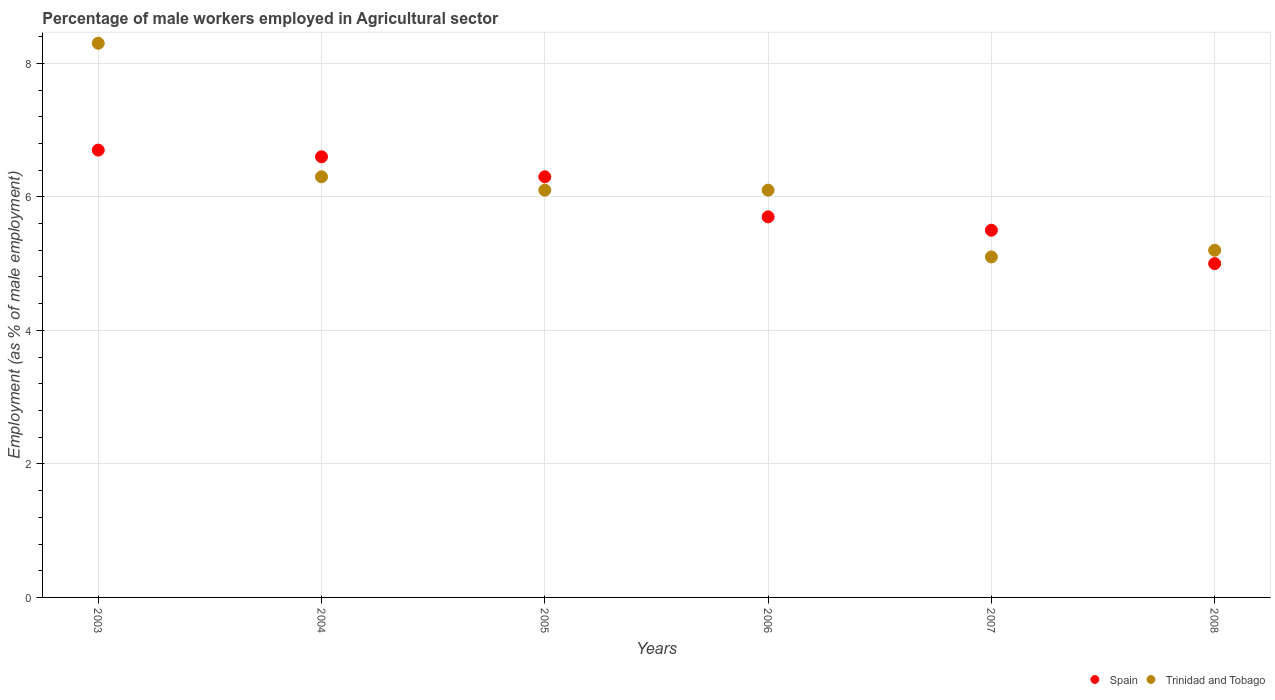What is the percentage of male workers employed in Agricultural sector in Trinidad and Tobago in 2008?
Your answer should be very brief. 5.2. Across all years, what is the maximum percentage of male workers employed in Agricultural sector in Spain?
Offer a terse response. 6.7. Across all years, what is the minimum percentage of male workers employed in Agricultural sector in Trinidad and Tobago?
Give a very brief answer. 5.1. In which year was the percentage of male workers employed in Agricultural sector in Spain maximum?
Give a very brief answer. 2003. What is the total percentage of male workers employed in Agricultural sector in Trinidad and Tobago in the graph?
Provide a short and direct response. 37.1. What is the difference between the percentage of male workers employed in Agricultural sector in Trinidad and Tobago in 2007 and that in 2008?
Keep it short and to the point. -0.1. What is the difference between the percentage of male workers employed in Agricultural sector in Trinidad and Tobago in 2006 and the percentage of male workers employed in Agricultural sector in Spain in 2008?
Keep it short and to the point. 1.1. What is the average percentage of male workers employed in Agricultural sector in Trinidad and Tobago per year?
Give a very brief answer. 6.18. In the year 2006, what is the difference between the percentage of male workers employed in Agricultural sector in Trinidad and Tobago and percentage of male workers employed in Agricultural sector in Spain?
Offer a very short reply. 0.4. What is the ratio of the percentage of male workers employed in Agricultural sector in Spain in 2006 to that in 2007?
Provide a short and direct response. 1.04. What is the difference between the highest and the second highest percentage of male workers employed in Agricultural sector in Spain?
Provide a short and direct response. 0.1. What is the difference between the highest and the lowest percentage of male workers employed in Agricultural sector in Trinidad and Tobago?
Make the answer very short. 3.2. In how many years, is the percentage of male workers employed in Agricultural sector in Spain greater than the average percentage of male workers employed in Agricultural sector in Spain taken over all years?
Your answer should be very brief. 3. Is the sum of the percentage of male workers employed in Agricultural sector in Trinidad and Tobago in 2004 and 2007 greater than the maximum percentage of male workers employed in Agricultural sector in Spain across all years?
Offer a terse response. Yes. How many years are there in the graph?
Your response must be concise. 6. Are the values on the major ticks of Y-axis written in scientific E-notation?
Give a very brief answer. No. What is the title of the graph?
Provide a short and direct response. Percentage of male workers employed in Agricultural sector. What is the label or title of the Y-axis?
Offer a very short reply. Employment (as % of male employment). What is the Employment (as % of male employment) of Spain in 2003?
Give a very brief answer. 6.7. What is the Employment (as % of male employment) of Trinidad and Tobago in 2003?
Ensure brevity in your answer.  8.3. What is the Employment (as % of male employment) of Spain in 2004?
Offer a very short reply. 6.6. What is the Employment (as % of male employment) in Trinidad and Tobago in 2004?
Your response must be concise. 6.3. What is the Employment (as % of male employment) in Spain in 2005?
Make the answer very short. 6.3. What is the Employment (as % of male employment) in Trinidad and Tobago in 2005?
Keep it short and to the point. 6.1. What is the Employment (as % of male employment) of Spain in 2006?
Make the answer very short. 5.7. What is the Employment (as % of male employment) of Trinidad and Tobago in 2006?
Make the answer very short. 6.1. What is the Employment (as % of male employment) in Trinidad and Tobago in 2007?
Offer a terse response. 5.1. What is the Employment (as % of male employment) in Trinidad and Tobago in 2008?
Offer a very short reply. 5.2. Across all years, what is the maximum Employment (as % of male employment) of Spain?
Your answer should be compact. 6.7. Across all years, what is the maximum Employment (as % of male employment) in Trinidad and Tobago?
Offer a terse response. 8.3. Across all years, what is the minimum Employment (as % of male employment) of Trinidad and Tobago?
Give a very brief answer. 5.1. What is the total Employment (as % of male employment) in Spain in the graph?
Provide a succinct answer. 35.8. What is the total Employment (as % of male employment) of Trinidad and Tobago in the graph?
Offer a very short reply. 37.1. What is the difference between the Employment (as % of male employment) in Trinidad and Tobago in 2003 and that in 2004?
Offer a very short reply. 2. What is the difference between the Employment (as % of male employment) in Spain in 2003 and that in 2005?
Keep it short and to the point. 0.4. What is the difference between the Employment (as % of male employment) in Spain in 2003 and that in 2006?
Offer a very short reply. 1. What is the difference between the Employment (as % of male employment) in Spain in 2003 and that in 2007?
Make the answer very short. 1.2. What is the difference between the Employment (as % of male employment) in Spain in 2003 and that in 2008?
Keep it short and to the point. 1.7. What is the difference between the Employment (as % of male employment) in Trinidad and Tobago in 2004 and that in 2005?
Keep it short and to the point. 0.2. What is the difference between the Employment (as % of male employment) in Trinidad and Tobago in 2004 and that in 2007?
Offer a very short reply. 1.2. What is the difference between the Employment (as % of male employment) in Spain in 2004 and that in 2008?
Give a very brief answer. 1.6. What is the difference between the Employment (as % of male employment) in Trinidad and Tobago in 2005 and that in 2006?
Offer a very short reply. 0. What is the difference between the Employment (as % of male employment) of Spain in 2005 and that in 2007?
Your answer should be compact. 0.8. What is the difference between the Employment (as % of male employment) in Trinidad and Tobago in 2006 and that in 2007?
Ensure brevity in your answer.  1. What is the difference between the Employment (as % of male employment) of Spain in 2006 and that in 2008?
Provide a short and direct response. 0.7. What is the difference between the Employment (as % of male employment) in Trinidad and Tobago in 2006 and that in 2008?
Provide a succinct answer. 0.9. What is the difference between the Employment (as % of male employment) in Trinidad and Tobago in 2007 and that in 2008?
Give a very brief answer. -0.1. What is the difference between the Employment (as % of male employment) in Spain in 2003 and the Employment (as % of male employment) in Trinidad and Tobago in 2005?
Provide a short and direct response. 0.6. What is the difference between the Employment (as % of male employment) of Spain in 2003 and the Employment (as % of male employment) of Trinidad and Tobago in 2006?
Ensure brevity in your answer.  0.6. What is the difference between the Employment (as % of male employment) in Spain in 2003 and the Employment (as % of male employment) in Trinidad and Tobago in 2007?
Keep it short and to the point. 1.6. What is the difference between the Employment (as % of male employment) in Spain in 2003 and the Employment (as % of male employment) in Trinidad and Tobago in 2008?
Offer a terse response. 1.5. What is the difference between the Employment (as % of male employment) in Spain in 2004 and the Employment (as % of male employment) in Trinidad and Tobago in 2006?
Your answer should be very brief. 0.5. What is the difference between the Employment (as % of male employment) in Spain in 2004 and the Employment (as % of male employment) in Trinidad and Tobago in 2007?
Offer a terse response. 1.5. What is the difference between the Employment (as % of male employment) in Spain in 2005 and the Employment (as % of male employment) in Trinidad and Tobago in 2007?
Your response must be concise. 1.2. What is the difference between the Employment (as % of male employment) of Spain in 2006 and the Employment (as % of male employment) of Trinidad and Tobago in 2008?
Your answer should be compact. 0.5. What is the average Employment (as % of male employment) of Spain per year?
Your answer should be compact. 5.97. What is the average Employment (as % of male employment) of Trinidad and Tobago per year?
Ensure brevity in your answer.  6.18. In the year 2003, what is the difference between the Employment (as % of male employment) of Spain and Employment (as % of male employment) of Trinidad and Tobago?
Your response must be concise. -1.6. In the year 2005, what is the difference between the Employment (as % of male employment) of Spain and Employment (as % of male employment) of Trinidad and Tobago?
Keep it short and to the point. 0.2. In the year 2007, what is the difference between the Employment (as % of male employment) in Spain and Employment (as % of male employment) in Trinidad and Tobago?
Provide a short and direct response. 0.4. What is the ratio of the Employment (as % of male employment) of Spain in 2003 to that in 2004?
Make the answer very short. 1.02. What is the ratio of the Employment (as % of male employment) of Trinidad and Tobago in 2003 to that in 2004?
Offer a very short reply. 1.32. What is the ratio of the Employment (as % of male employment) of Spain in 2003 to that in 2005?
Your response must be concise. 1.06. What is the ratio of the Employment (as % of male employment) of Trinidad and Tobago in 2003 to that in 2005?
Provide a succinct answer. 1.36. What is the ratio of the Employment (as % of male employment) of Spain in 2003 to that in 2006?
Give a very brief answer. 1.18. What is the ratio of the Employment (as % of male employment) in Trinidad and Tobago in 2003 to that in 2006?
Your answer should be very brief. 1.36. What is the ratio of the Employment (as % of male employment) of Spain in 2003 to that in 2007?
Ensure brevity in your answer.  1.22. What is the ratio of the Employment (as % of male employment) in Trinidad and Tobago in 2003 to that in 2007?
Provide a short and direct response. 1.63. What is the ratio of the Employment (as % of male employment) in Spain in 2003 to that in 2008?
Make the answer very short. 1.34. What is the ratio of the Employment (as % of male employment) in Trinidad and Tobago in 2003 to that in 2008?
Offer a terse response. 1.6. What is the ratio of the Employment (as % of male employment) in Spain in 2004 to that in 2005?
Your answer should be compact. 1.05. What is the ratio of the Employment (as % of male employment) of Trinidad and Tobago in 2004 to that in 2005?
Keep it short and to the point. 1.03. What is the ratio of the Employment (as % of male employment) in Spain in 2004 to that in 2006?
Your answer should be very brief. 1.16. What is the ratio of the Employment (as % of male employment) of Trinidad and Tobago in 2004 to that in 2006?
Offer a very short reply. 1.03. What is the ratio of the Employment (as % of male employment) in Trinidad and Tobago in 2004 to that in 2007?
Keep it short and to the point. 1.24. What is the ratio of the Employment (as % of male employment) of Spain in 2004 to that in 2008?
Ensure brevity in your answer.  1.32. What is the ratio of the Employment (as % of male employment) in Trinidad and Tobago in 2004 to that in 2008?
Your response must be concise. 1.21. What is the ratio of the Employment (as % of male employment) in Spain in 2005 to that in 2006?
Provide a short and direct response. 1.11. What is the ratio of the Employment (as % of male employment) in Spain in 2005 to that in 2007?
Offer a terse response. 1.15. What is the ratio of the Employment (as % of male employment) in Trinidad and Tobago in 2005 to that in 2007?
Offer a terse response. 1.2. What is the ratio of the Employment (as % of male employment) in Spain in 2005 to that in 2008?
Give a very brief answer. 1.26. What is the ratio of the Employment (as % of male employment) of Trinidad and Tobago in 2005 to that in 2008?
Provide a short and direct response. 1.17. What is the ratio of the Employment (as % of male employment) of Spain in 2006 to that in 2007?
Offer a very short reply. 1.04. What is the ratio of the Employment (as % of male employment) of Trinidad and Tobago in 2006 to that in 2007?
Provide a short and direct response. 1.2. What is the ratio of the Employment (as % of male employment) of Spain in 2006 to that in 2008?
Provide a succinct answer. 1.14. What is the ratio of the Employment (as % of male employment) in Trinidad and Tobago in 2006 to that in 2008?
Give a very brief answer. 1.17. What is the ratio of the Employment (as % of male employment) of Spain in 2007 to that in 2008?
Offer a very short reply. 1.1. What is the ratio of the Employment (as % of male employment) of Trinidad and Tobago in 2007 to that in 2008?
Make the answer very short. 0.98. What is the difference between the highest and the second highest Employment (as % of male employment) of Trinidad and Tobago?
Provide a short and direct response. 2. What is the difference between the highest and the lowest Employment (as % of male employment) of Spain?
Give a very brief answer. 1.7. What is the difference between the highest and the lowest Employment (as % of male employment) of Trinidad and Tobago?
Offer a very short reply. 3.2. 